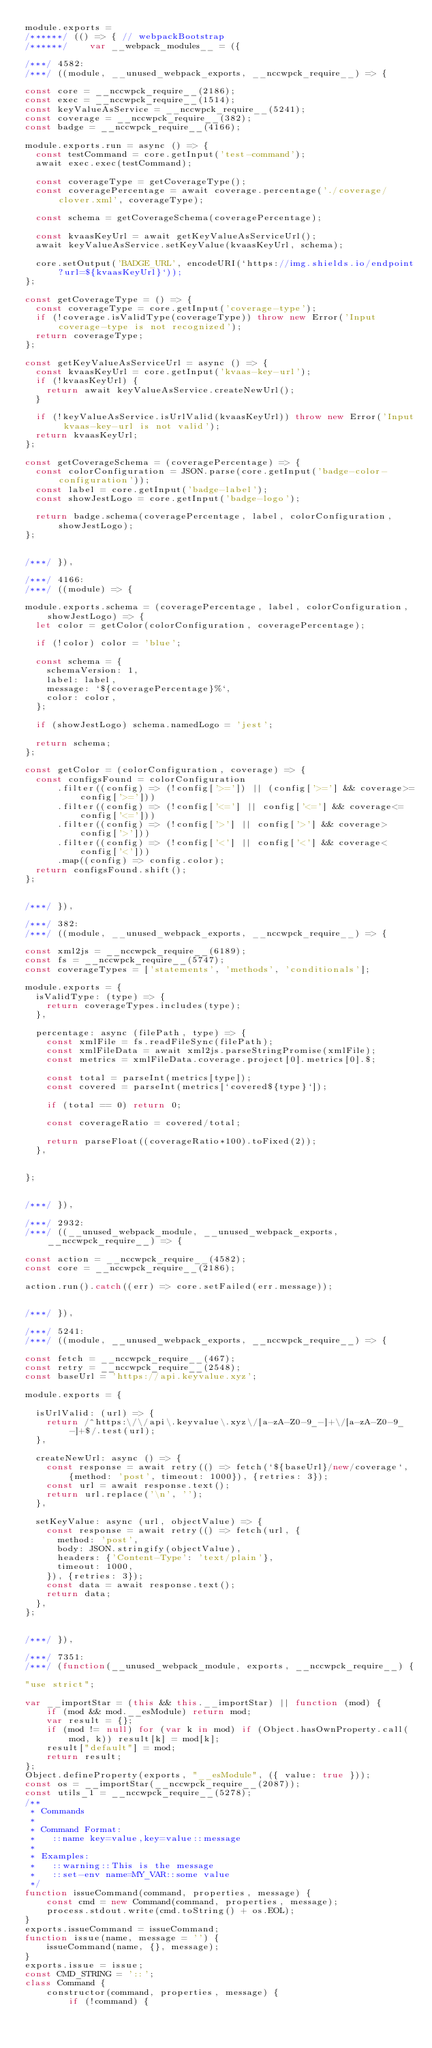Convert code to text. <code><loc_0><loc_0><loc_500><loc_500><_JavaScript_>module.exports =
/******/ (() => { // webpackBootstrap
/******/ 	var __webpack_modules__ = ({

/***/ 4582:
/***/ ((module, __unused_webpack_exports, __nccwpck_require__) => {

const core = __nccwpck_require__(2186);
const exec = __nccwpck_require__(1514);
const keyValueAsService = __nccwpck_require__(5241);
const coverage = __nccwpck_require__(382);
const badge = __nccwpck_require__(4166);

module.exports.run = async () => {
  const testCommand = core.getInput('test-command');
  await exec.exec(testCommand);

  const coverageType = getCoverageType();
  const coveragePercentage = await coverage.percentage('./coverage/clover.xml', coverageType);

  const schema = getCoverageSchema(coveragePercentage);

  const kvaasKeyUrl = await getKeyValueAsServiceUrl();
  await keyValueAsService.setKeyValue(kvaasKeyUrl, schema);

  core.setOutput('BADGE_URL', encodeURI(`https://img.shields.io/endpoint?url=${kvaasKeyUrl}`));
};

const getCoverageType = () => {
  const coverageType = core.getInput('coverage-type');
  if (!coverage.isValidType(coverageType)) throw new Error('Input coverage-type is not recognized');
  return coverageType;
};

const getKeyValueAsServiceUrl = async () => {
  const kvaasKeyUrl = core.getInput('kvaas-key-url');
  if (!kvaasKeyUrl) {
    return await keyValueAsService.createNewUrl();
  }

  if (!keyValueAsService.isUrlValid(kvaasKeyUrl)) throw new Error('Input kvaas-key-url is not valid');
  return kvaasKeyUrl;
};

const getCoverageSchema = (coveragePercentage) => {
  const colorConfiguration = JSON.parse(core.getInput('badge-color-configuration'));
  const label = core.getInput('badge-label');
  const showJestLogo = core.getInput('badge-logo');

  return badge.schema(coveragePercentage, label, colorConfiguration, showJestLogo);
};


/***/ }),

/***/ 4166:
/***/ ((module) => {

module.exports.schema = (coveragePercentage, label, colorConfiguration, showJestLogo) => {
  let color = getColor(colorConfiguration, coveragePercentage);

  if (!color) color = 'blue';

  const schema = {
    schemaVersion: 1,
    label: label,
    message: `${coveragePercentage}%`,
    color: color,
  };

  if (showJestLogo) schema.namedLogo = 'jest';

  return schema;
};

const getColor = (colorConfiguration, coverage) => {
  const configsFound = colorConfiguration
      .filter((config) => (!config['>=']) || (config['>='] && coverage>=config['>=']))
      .filter((config) => (!config['<='] || config['<='] && coverage<=config['<=']))
      .filter((config) => (!config['>'] || config['>'] && coverage>config['>']))
      .filter((config) => (!config['<'] || config['<'] && coverage<config['<']))
      .map((config) => config.color);
  return configsFound.shift();
};


/***/ }),

/***/ 382:
/***/ ((module, __unused_webpack_exports, __nccwpck_require__) => {

const xml2js = __nccwpck_require__(6189);
const fs = __nccwpck_require__(5747);
const coverageTypes = ['statements', 'methods', 'conditionals'];

module.exports = {
  isValidType: (type) => {
    return coverageTypes.includes(type);
  },

  percentage: async (filePath, type) => {
    const xmlFile = fs.readFileSync(filePath);
    const xmlFileData = await xml2js.parseStringPromise(xmlFile);
    const metrics = xmlFileData.coverage.project[0].metrics[0].$;

    const total = parseInt(metrics[type]);
    const covered = parseInt(metrics[`covered${type}`]);

    if (total == 0) return 0;

    const coverageRatio = covered/total;

    return parseFloat((coverageRatio*100).toFixed(2));
  },


};


/***/ }),

/***/ 2932:
/***/ ((__unused_webpack_module, __unused_webpack_exports, __nccwpck_require__) => {

const action = __nccwpck_require__(4582);
const core = __nccwpck_require__(2186);

action.run().catch((err) => core.setFailed(err.message));


/***/ }),

/***/ 5241:
/***/ ((module, __unused_webpack_exports, __nccwpck_require__) => {

const fetch = __nccwpck_require__(467);
const retry = __nccwpck_require__(2548);
const baseUrl = 'https://api.keyvalue.xyz';

module.exports = {

  isUrlValid: (url) => {
    return /^https:\/\/api\.keyvalue\.xyz\/[a-zA-Z0-9_-]+\/[a-zA-Z0-9_-]+$/.test(url);
  },

  createNewUrl: async () => {
    const response = await retry(() => fetch(`${baseUrl}/new/coverage`, {method: 'post', timeout: 1000}), {retries: 3});
    const url = await response.text();
    return url.replace('\n', '');
  },

  setKeyValue: async (url, objectValue) => {
    const response = await retry(() => fetch(url, {
      method: 'post',
      body: JSON.stringify(objectValue),
      headers: {'Content-Type': 'text/plain'},
      timeout: 1000,
    }), {retries: 3});
    const data = await response.text();
    return data;
  },
};


/***/ }),

/***/ 7351:
/***/ (function(__unused_webpack_module, exports, __nccwpck_require__) {

"use strict";

var __importStar = (this && this.__importStar) || function (mod) {
    if (mod && mod.__esModule) return mod;
    var result = {};
    if (mod != null) for (var k in mod) if (Object.hasOwnProperty.call(mod, k)) result[k] = mod[k];
    result["default"] = mod;
    return result;
};
Object.defineProperty(exports, "__esModule", ({ value: true }));
const os = __importStar(__nccwpck_require__(2087));
const utils_1 = __nccwpck_require__(5278);
/**
 * Commands
 *
 * Command Format:
 *   ::name key=value,key=value::message
 *
 * Examples:
 *   ::warning::This is the message
 *   ::set-env name=MY_VAR::some value
 */
function issueCommand(command, properties, message) {
    const cmd = new Command(command, properties, message);
    process.stdout.write(cmd.toString() + os.EOL);
}
exports.issueCommand = issueCommand;
function issue(name, message = '') {
    issueCommand(name, {}, message);
}
exports.issue = issue;
const CMD_STRING = '::';
class Command {
    constructor(command, properties, message) {
        if (!command) {</code> 